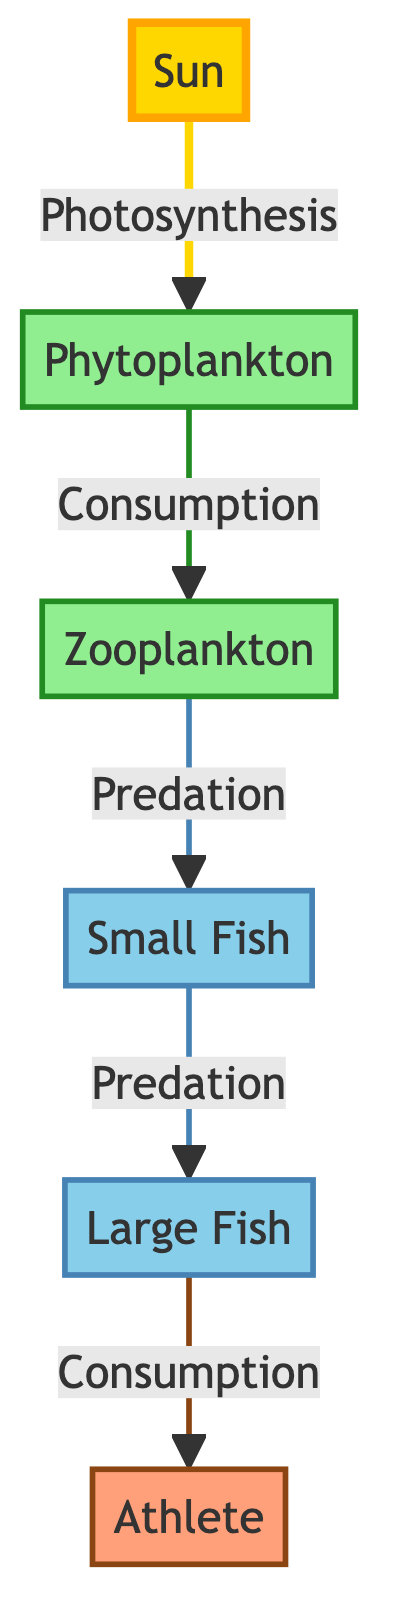What is the primary energy source in this food chain? The diagram shows the sun as the initial source of energy, indicating that it sustains the entire food chain through photosynthesis.
Answer: Sun How many trophic levels are represented in the diagram? There are five levels in total: Sun, Phytoplankton, Zooplankton, Small Fish, and Large Fish. Counting these, we find that there are five distinct trophic levels.
Answer: 5 Which organism in the diagram is a primary producer? The phytoplankton is identified as the primary producer due to its role in photosynthesis, converting sunlight into energy.
Answer: Phytoplankton What does zooplankton consume in the food chain? The diagram indicates that zooplankton primarily consumes phytoplankton, as seen from the arrow indicating this relationship.
Answer: Phytoplankton Which organism is at the top of the food chain? The large fish occupies the highest trophic level in this food chain, showing that it is the top predator consuming smaller fish and, consequently, being consumed by humans.
Answer: Large Fish How many types of fish are present in the diagram? The diagram showcases two types of fish: small fish and large fish, identifying them individually. Therefore, the total count is two distinct fish types.
Answer: 2 What is the relationship between large fish and humans? According to the diagram, large fish are consumed by humans, showing a direct predation or consumption link between these two organisms.
Answer: Consumption What type of organisms are phytoplankton and zooplankton classified as in this diagram? Phytoplankton is classified as a primary producer, while zooplankton is a primary consumer, showing their respective roles in this trophic structure.
Answer: Primary producer and primary consumer What energy conversion process do phytoplankton use? Phytoplankton uses photosynthesis to convert sunlight into energy, thus playing a crucial role in energy flow within the food chain.
Answer: Photosynthesis 